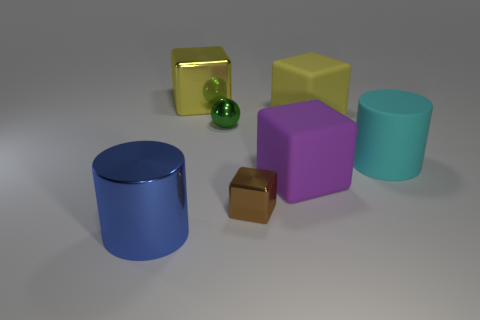What number of big cylinders are behind the big yellow thing to the right of the small brown cube that is to the right of the green ball?
Offer a terse response. 0. Are there more big metallic cylinders that are left of the tiny ball than big blue cylinders behind the purple rubber block?
Offer a very short reply. Yes. How many blue things have the same shape as the tiny green thing?
Keep it short and to the point. 0. What number of things are large objects that are behind the purple matte object or large objects on the left side of the green metal sphere?
Provide a short and direct response. 4. What material is the cylinder that is behind the big shiny object that is in front of the tiny metallic object that is behind the brown metallic cube?
Your answer should be very brief. Rubber. There is a big shiny object behind the blue thing; does it have the same color as the large metal cylinder?
Your response must be concise. No. There is a cube that is right of the small brown cube and in front of the large cyan object; what material is it?
Make the answer very short. Rubber. Is there a metallic cylinder of the same size as the purple matte object?
Offer a terse response. Yes. How many purple metal cubes are there?
Give a very brief answer. 0. There is a green shiny object; how many shiny cylinders are on the right side of it?
Your answer should be compact. 0. 